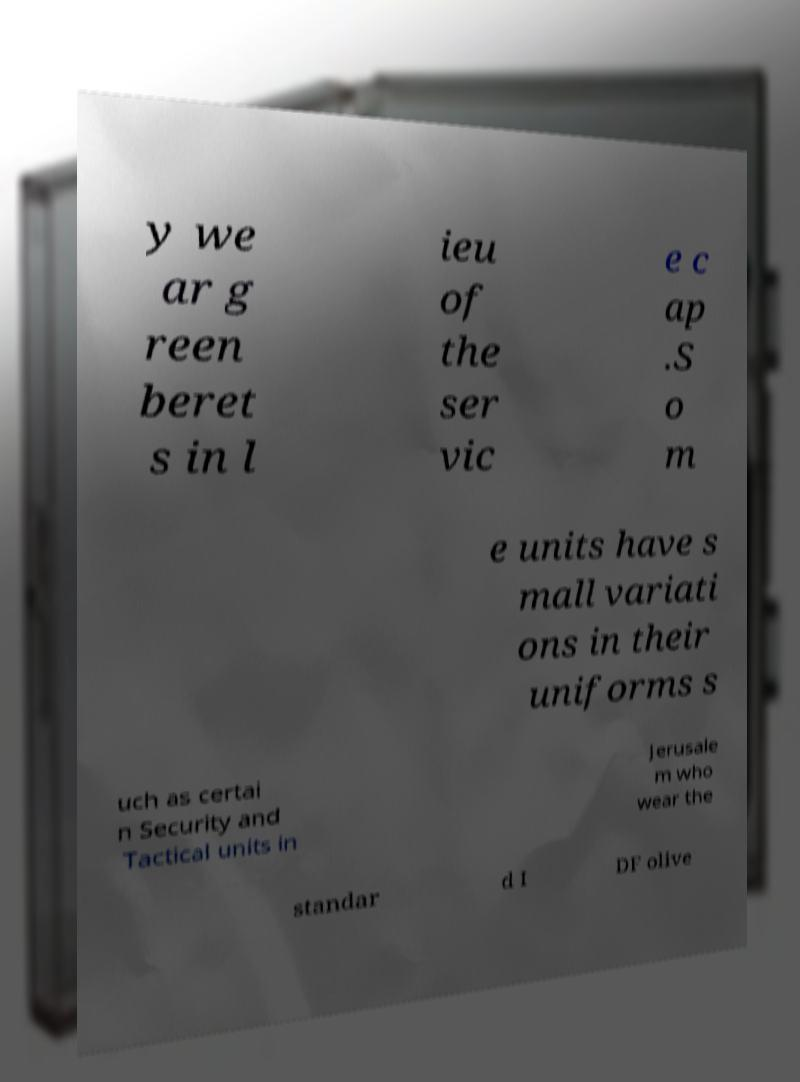Can you accurately transcribe the text from the provided image for me? y we ar g reen beret s in l ieu of the ser vic e c ap .S o m e units have s mall variati ons in their uniforms s uch as certai n Security and Tactical units in Jerusale m who wear the standar d I DF olive 